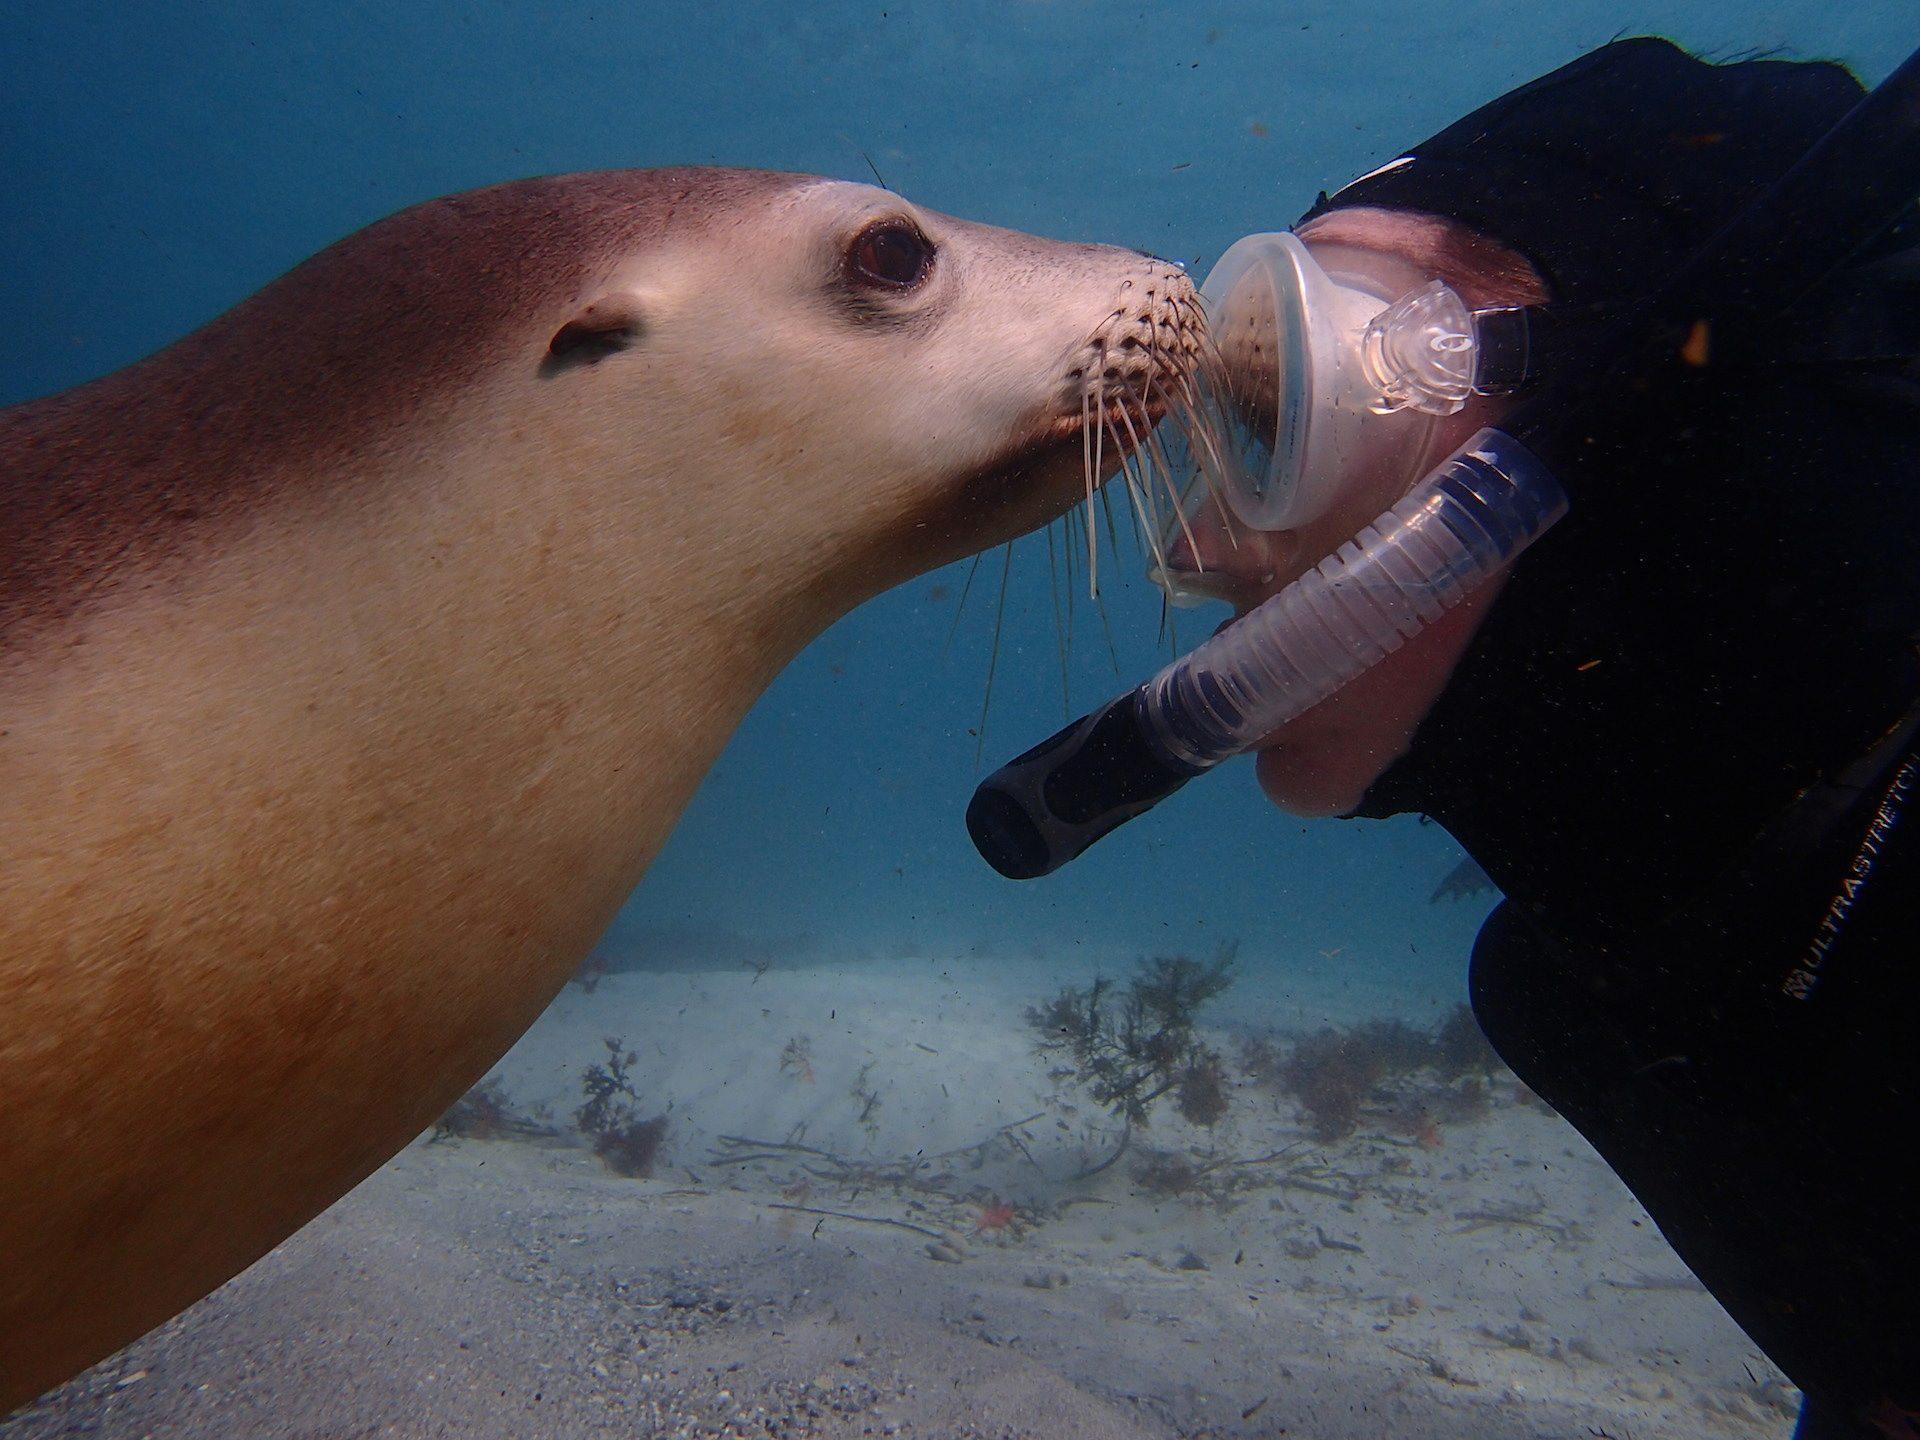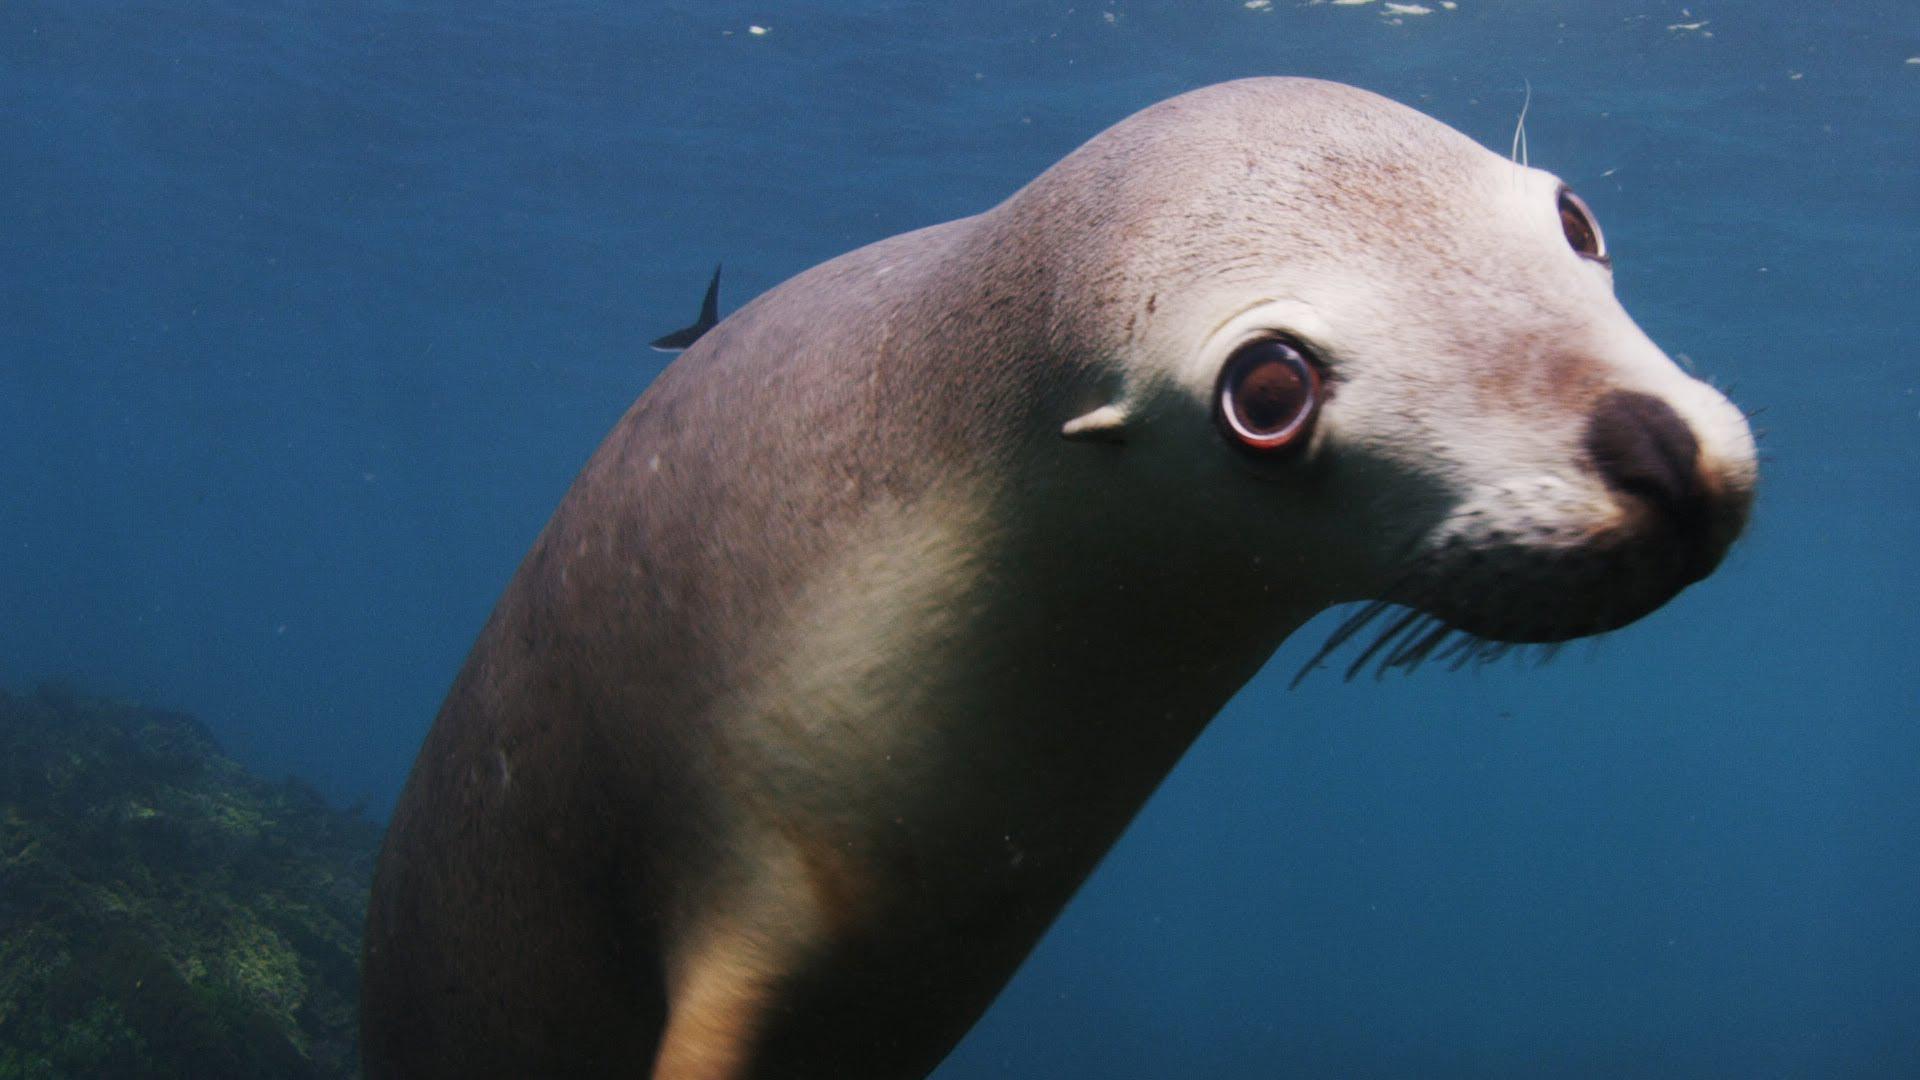The first image is the image on the left, the second image is the image on the right. Examine the images to the left and right. Is the description "In at least one image there is a sea lion swimming alone with no other mammals present." accurate? Answer yes or no. Yes. The first image is the image on the left, the second image is the image on the right. Considering the images on both sides, is "The left image shows a diver in a wetsuit interacting with a seal, but the right image does not include a diver." valid? Answer yes or no. Yes. 